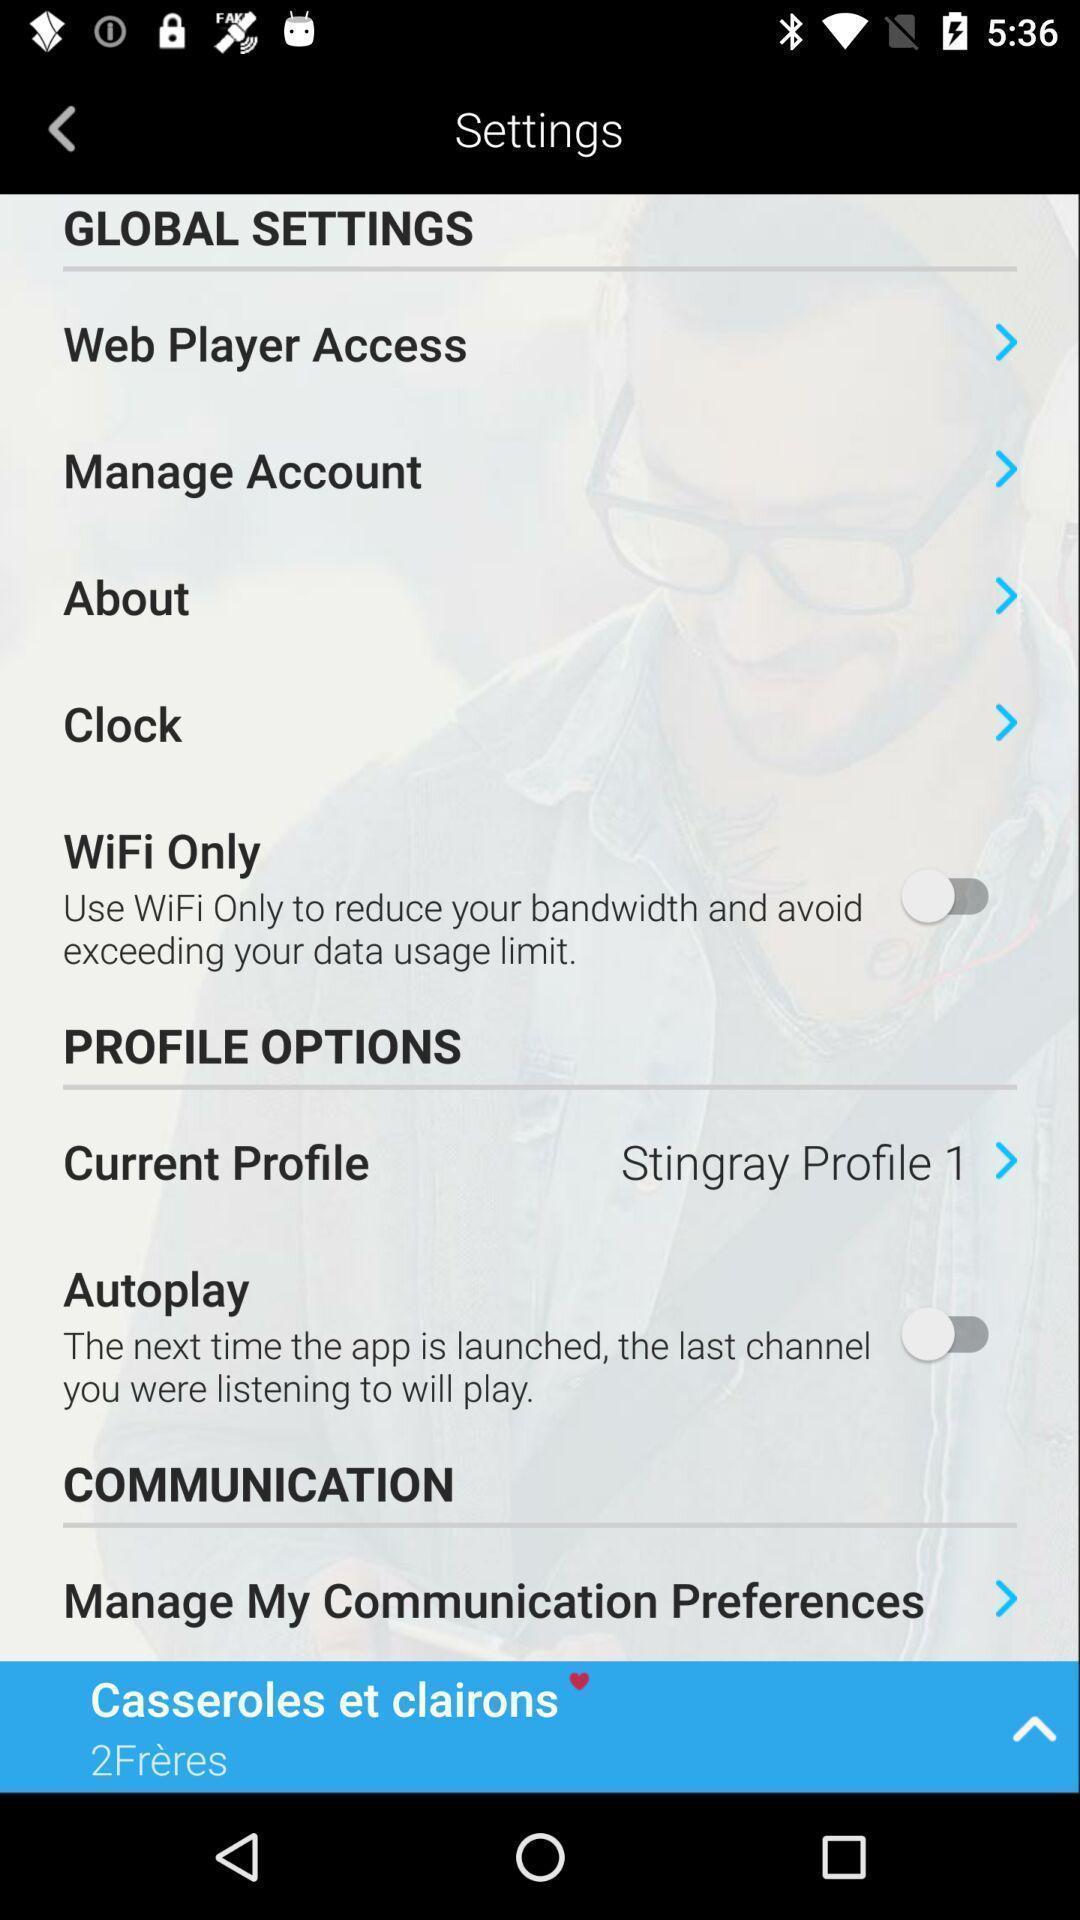What can you discern from this picture? Settings page of a music app. 